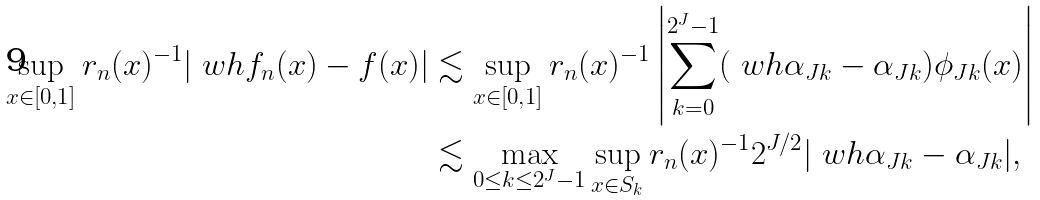Convert formula to latex. <formula><loc_0><loc_0><loc_500><loc_500>\sup _ { x \in [ 0 , 1 ] } r _ { n } ( x ) ^ { - 1 } | \ w h f _ { n } ( x ) - f ( x ) | & \lesssim \sup _ { x \in [ 0 , 1 ] } r _ { n } ( x ) ^ { - 1 } \left | \sum _ { k = 0 } ^ { 2 ^ { J } - 1 } ( \ w h \alpha _ { J k } - \alpha _ { J k } ) \phi _ { J k } ( x ) \right | \\ & \lesssim \max _ { 0 \leq k \leq 2 ^ { J } - 1 } \sup _ { x \in S _ { k } } r _ { n } ( x ) ^ { - 1 } 2 ^ { J / 2 } | \ w h \alpha _ { J k } - \alpha _ { J k } | ,</formula> 